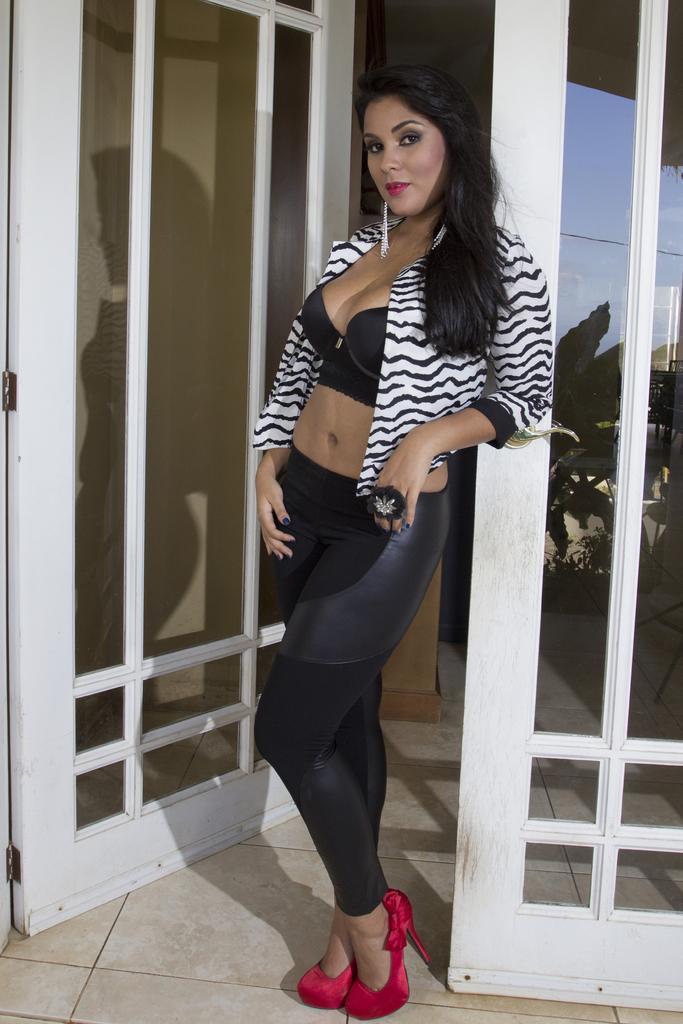Could you give a brief overview of what you see in this image? In this picture, there is a woman in the center standing beside the door. She is wearing a shrug and black trousers. 